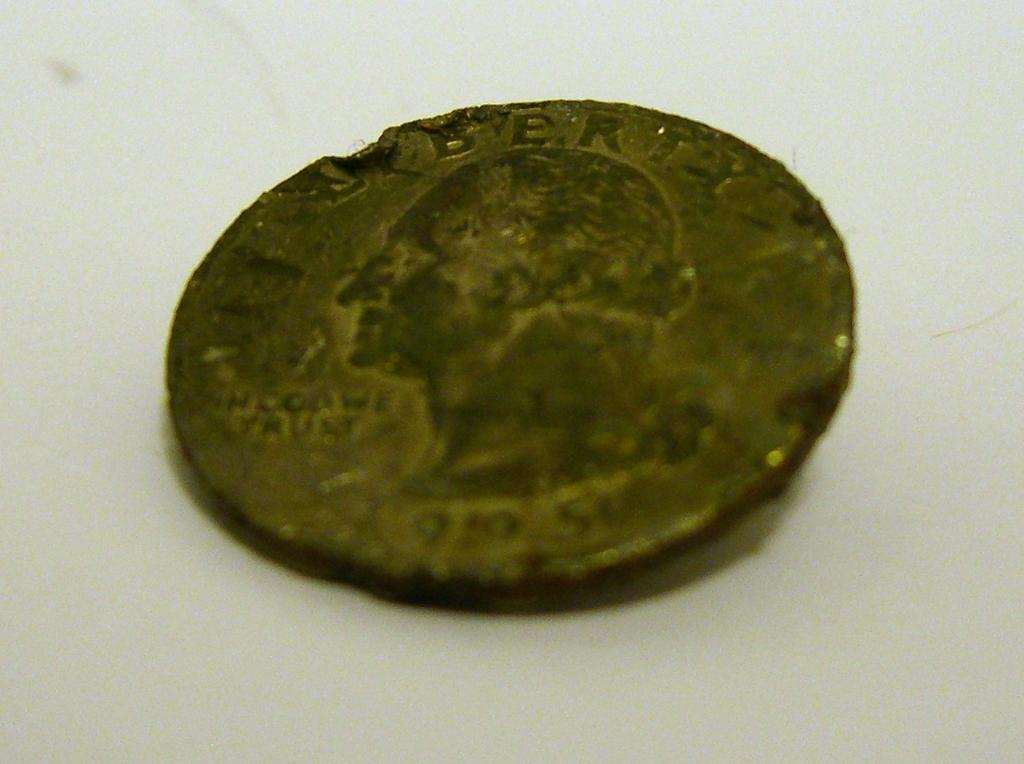<image>
Relay a brief, clear account of the picture shown. Dirty coin which has a face of the President and the word Liberty on top. 